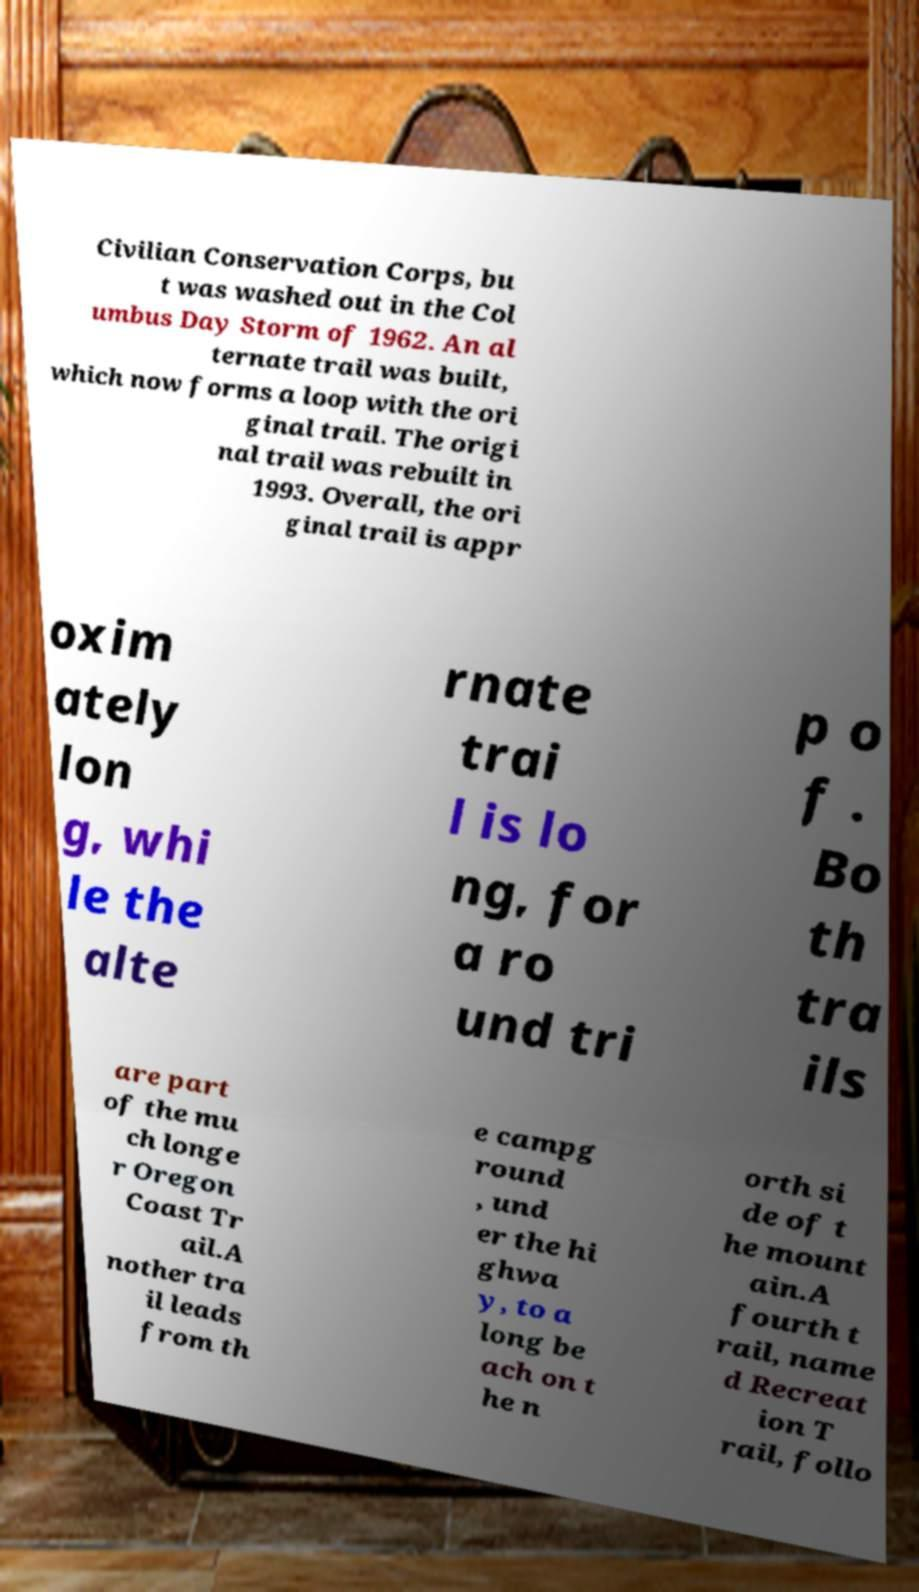Can you read and provide the text displayed in the image?This photo seems to have some interesting text. Can you extract and type it out for me? Civilian Conservation Corps, bu t was washed out in the Col umbus Day Storm of 1962. An al ternate trail was built, which now forms a loop with the ori ginal trail. The origi nal trail was rebuilt in 1993. Overall, the ori ginal trail is appr oxim ately lon g, whi le the alte rnate trai l is lo ng, for a ro und tri p o f . Bo th tra ils are part of the mu ch longe r Oregon Coast Tr ail.A nother tra il leads from th e campg round , und er the hi ghwa y, to a long be ach on t he n orth si de of t he mount ain.A fourth t rail, name d Recreat ion T rail, follo 